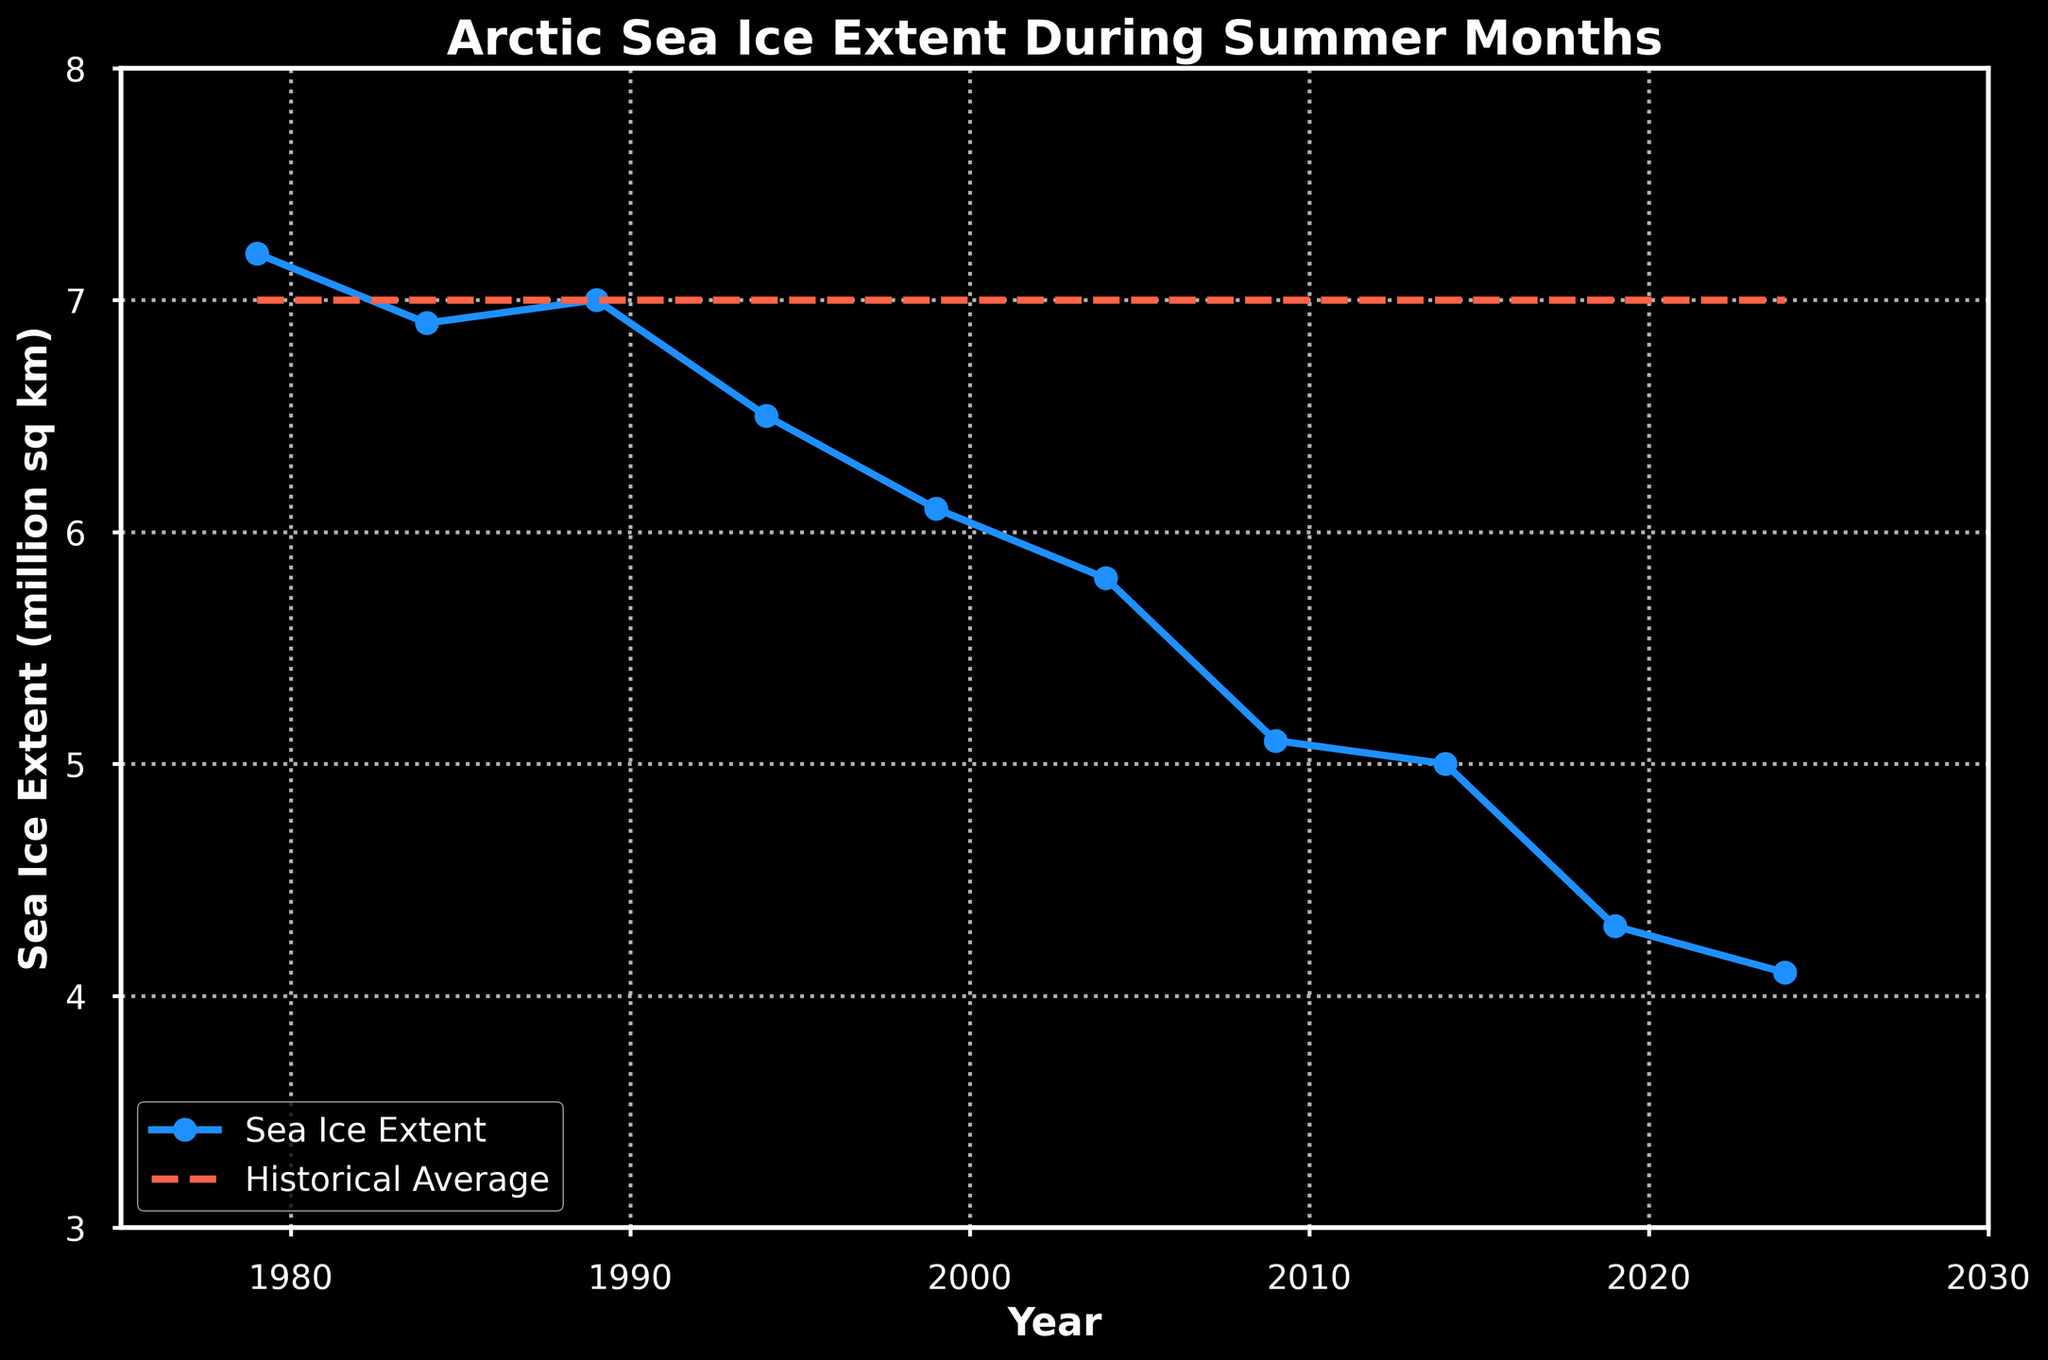What was the sea ice extent in 1979, and how does it compare to the sea ice extent in 2024? The sea ice extent in 1979 was 7.2 million sq km, whereas in 2024 it was 4.1 million sq km. The difference is calculated as 7.2 - 4.1 = 3.1 million sq km. Therefore, the sea ice extent in 2024 decreased by 3.1 million sq km compared to 1979.
Answer: The sea ice extent in 2024 decreased by 3.1 million sq km compared to 1979 In which year did the Arctic sea ice extent first drop below 6 million sq km? By observing the figure, the first year that the Arctic sea ice extent dropped below 6 million sq km is 1999, where the extent is visibly at 6.1 million sq km.
Answer: 1999 How many years show a sea ice extent equal to or below the historical average? Comparing each data point to the historical average line (7.0 million sq km), the years 1994, 1999, 2004, 2009, 2014, 2019, and 2024 show a sea ice extent equal to or below the historical average. This gives us a count of 7 years.
Answer: 7 years Which year showed the maximum decline in sea ice extent compared to the historical average? To find the maximum decline, calculate the difference between sea ice extent and the historical average for each year. The maximum decline occurs in 2019 with a sea ice extent of 4.3 million sq km against a historical average of 7.0 million sq km, giving a decline of 2.7 million sq km.
Answer: 2019 How has the sea ice extent changed from 2009 to 2019? The sea ice extent in 2009 was 5.1 million sq km, and in 2019 it was 4.3 million sq km. The change is calculated as 5.1 - 4.3 = 0.8 million sq km. Thus, the sea ice extent decreased by 0.8 million sq km from 2009 to 2019.
Answer: Decreased by 0.8 million sq km What is the overall trend in the Arctic sea ice extent from 1979 to 2024? Observing the plot, the overall trend from 1979 (7.2 million sq km) to 2024 (4.1 million sq km) is a consistent decline in sea ice extent. The line shows a clear downward trajectory.
Answer: Declining trend Which year had the closest sea ice extent to the historical average after 1979? Examining the figure, the year with the closest sea ice extent to the historical average (7.0 million sq km) after 1979 is 1989, where the sea ice extent is also approximately 7.0 million sq km.
Answer: 1989 In which period (1979-1999 or 1999-2024) did the Arctic sea ice extent decrease more significantly? Calculate the total decrease in each period:
- From 1979 to 1999: 7.2 - 6.1 = 1.1 million sq km.
- From 1999 to 2024: 6.1 - 4.1 = 2.0 million sq km.
The sea ice extent decreased more significantly in the period from 1999 to 2024.
Answer: 1999-2024 By how much did the sea ice extent decrease from 1989 to 2004? The sea ice extent in 1989 was 7.0 million sq km and in 2004 it was 5.8 million sq km. The decrease is calculated as 7.0 - 5.8 = 1.2 million sq km.
Answer: Decrease by 1.2 million sq km What color represents the historical average line on the plot? Observing the visual attributes of the plot, the historical average line is represented by a red dashed line.
Answer: Red 